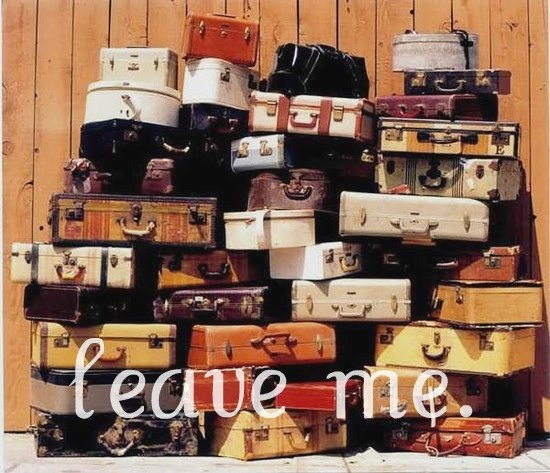Describe the objects in this image and their specific colors. I can see suitcase in white, black, lightgray, maroon, and brown tones, suitcase in white, brown, black, and maroon tones, suitcase in white, khaki, brown, and tan tones, suitcase in white, tan, and beige tones, and suitcase in white, tan, maroon, and brown tones in this image. 